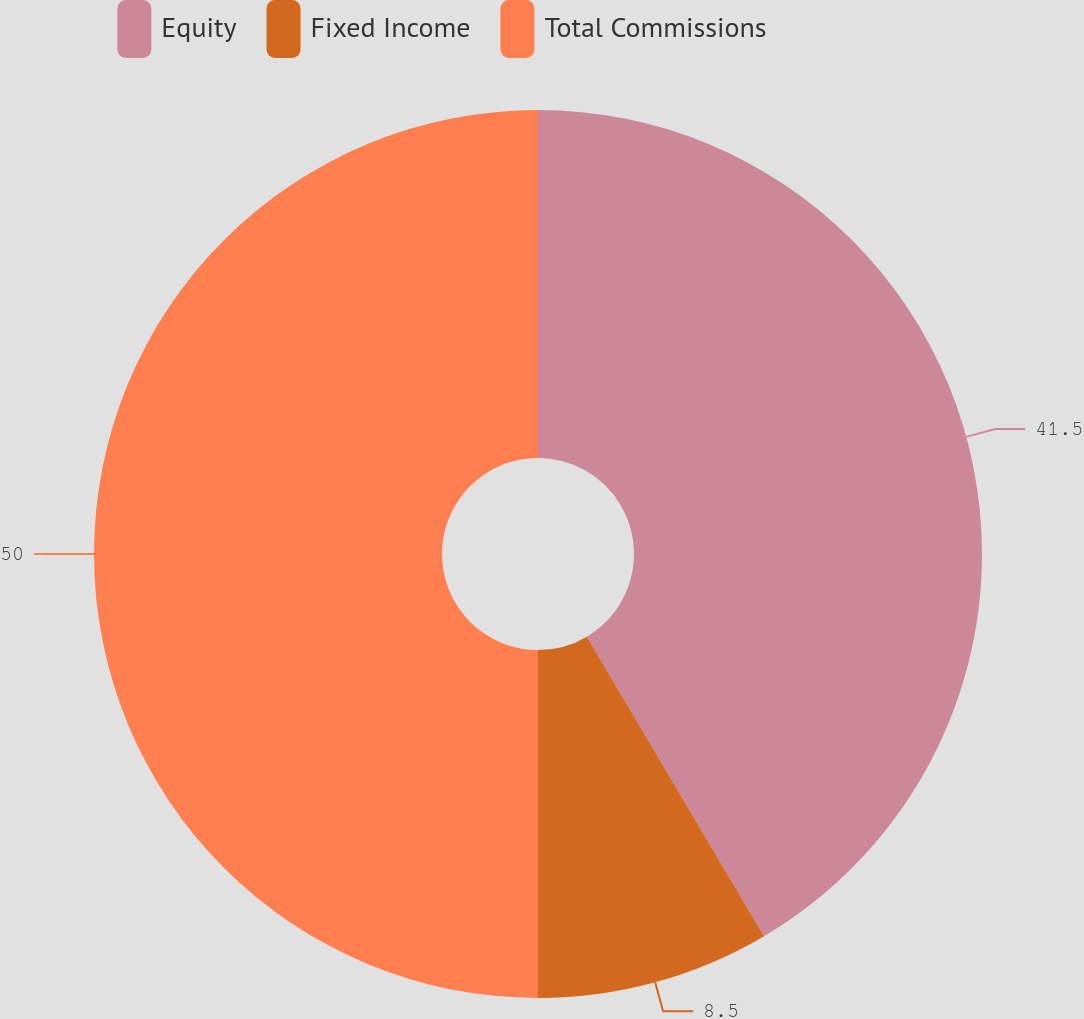Convert chart to OTSL. <chart><loc_0><loc_0><loc_500><loc_500><pie_chart><fcel>Equity<fcel>Fixed Income<fcel>Total Commissions<nl><fcel>41.5%<fcel>8.5%<fcel>50.0%<nl></chart> 